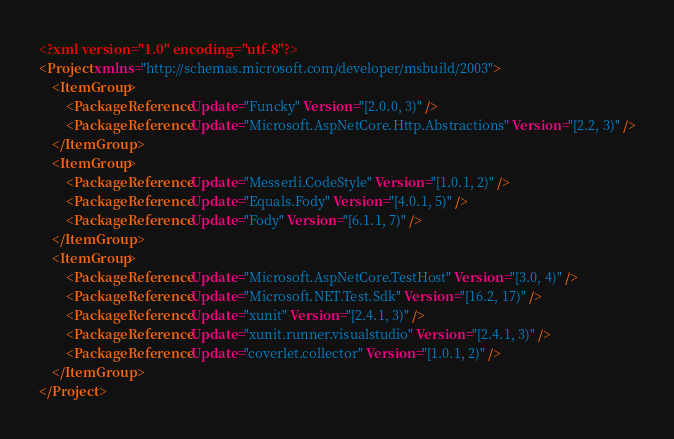Convert code to text. <code><loc_0><loc_0><loc_500><loc_500><_XML_><?xml version="1.0" encoding="utf-8"?>
<Project xmlns="http://schemas.microsoft.com/developer/msbuild/2003">
	<ItemGroup>
		<PackageReference Update="Funcky" Version="[2.0.0, 3)" />
		<PackageReference Update="Microsoft.AspNetCore.Http.Abstractions" Version="[2.2, 3)" />
	</ItemGroup>
	<ItemGroup>
		<PackageReference Update="Messerli.CodeStyle" Version="[1.0.1, 2)" />
		<PackageReference Update="Equals.Fody" Version="[4.0.1, 5)" />
		<PackageReference Update="Fody" Version="[6.1.1, 7)" />
	</ItemGroup>
	<ItemGroup>
		<PackageReference Update="Microsoft.AspNetCore.TestHost" Version="[3.0, 4)" />
		<PackageReference Update="Microsoft.NET.Test.Sdk" Version="[16.2, 17)" />
		<PackageReference Update="xunit" Version="[2.4.1, 3)" />
		<PackageReference Update="xunit.runner.visualstudio" Version="[2.4.1, 3)" />
		<PackageReference Update="coverlet.collector" Version="[1.0.1, 2)" />
	</ItemGroup>
</Project>
</code> 